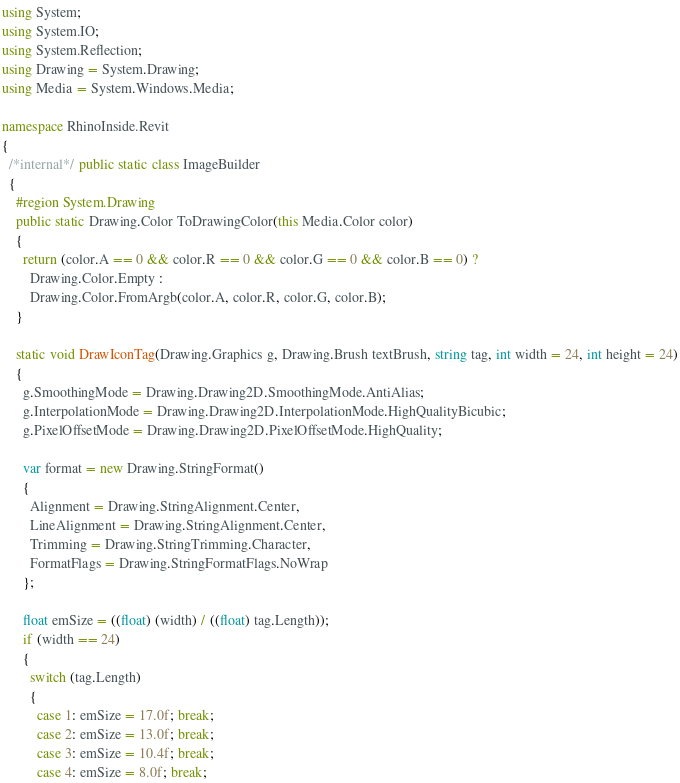<code> <loc_0><loc_0><loc_500><loc_500><_C#_>using System;
using System.IO;
using System.Reflection;
using Drawing = System.Drawing;
using Media = System.Windows.Media;

namespace RhinoInside.Revit
{
  /*internal*/ public static class ImageBuilder
  {
    #region System.Drawing
    public static Drawing.Color ToDrawingColor(this Media.Color color)
    {
      return (color.A == 0 && color.R == 0 && color.G == 0 && color.B == 0) ?
        Drawing.Color.Empty :
        Drawing.Color.FromArgb(color.A, color.R, color.G, color.B);
    }

    static void DrawIconTag(Drawing.Graphics g, Drawing.Brush textBrush, string tag, int width = 24, int height = 24)
    {
      g.SmoothingMode = Drawing.Drawing2D.SmoothingMode.AntiAlias;
      g.InterpolationMode = Drawing.Drawing2D.InterpolationMode.HighQualityBicubic;
      g.PixelOffsetMode = Drawing.Drawing2D.PixelOffsetMode.HighQuality;

      var format = new Drawing.StringFormat()
      {
        Alignment = Drawing.StringAlignment.Center,
        LineAlignment = Drawing.StringAlignment.Center,
        Trimming = Drawing.StringTrimming.Character,
        FormatFlags = Drawing.StringFormatFlags.NoWrap
      };

      float emSize = ((float) (width) / ((float) tag.Length));
      if (width == 24)
      {
        switch (tag.Length)
        {
          case 1: emSize = 17.0f; break;
          case 2: emSize = 13.0f; break;
          case 3: emSize = 10.4f; break;
          case 4: emSize = 8.0f; break;</code> 